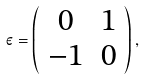Convert formula to latex. <formula><loc_0><loc_0><loc_500><loc_500>\varepsilon = \left ( \begin{array} { c c } 0 & 1 \\ - 1 & 0 \end{array} \right ) ,</formula> 